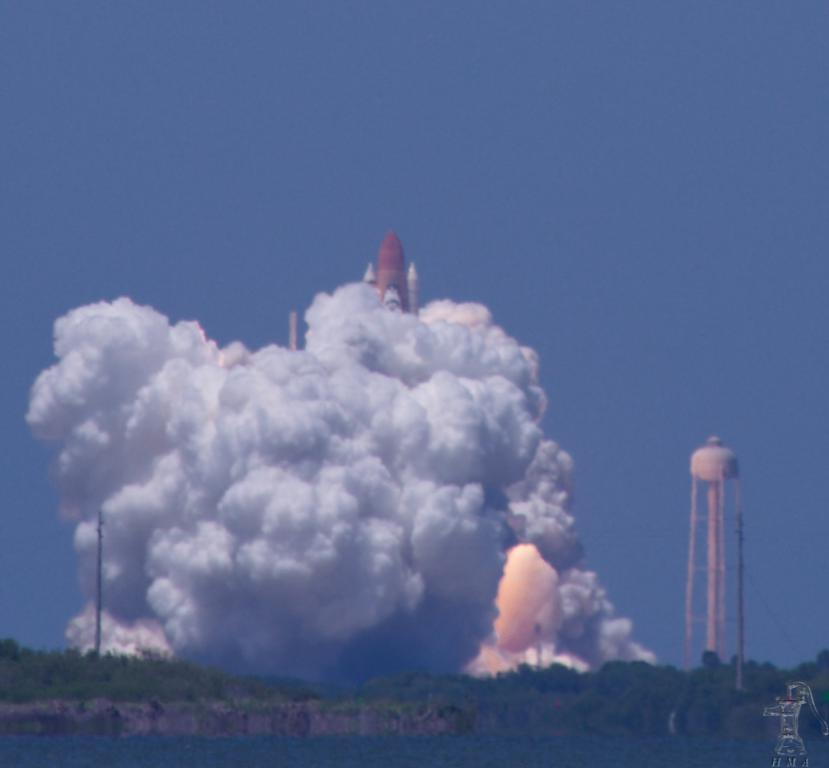What type of vegetation can be seen in the image? There are trees in the image. What type of vehicle is present in the image? There is a tank in the image. What type of transportation is also present in the image? There is a rocket in the image. What can be seen coming out of the tank or rocket in the image? There is smoke visible in the image. What is visible in the background of the image? The sky is visible in the background of the image. What event is being held in the image? There is no event depicted in the image; it features trees, a tank, a rocket, smoke, and the sky. What level of difficulty is indicated by the watermark in the image? There is no indication of difficulty or any event in the image; it only has a watermark. 